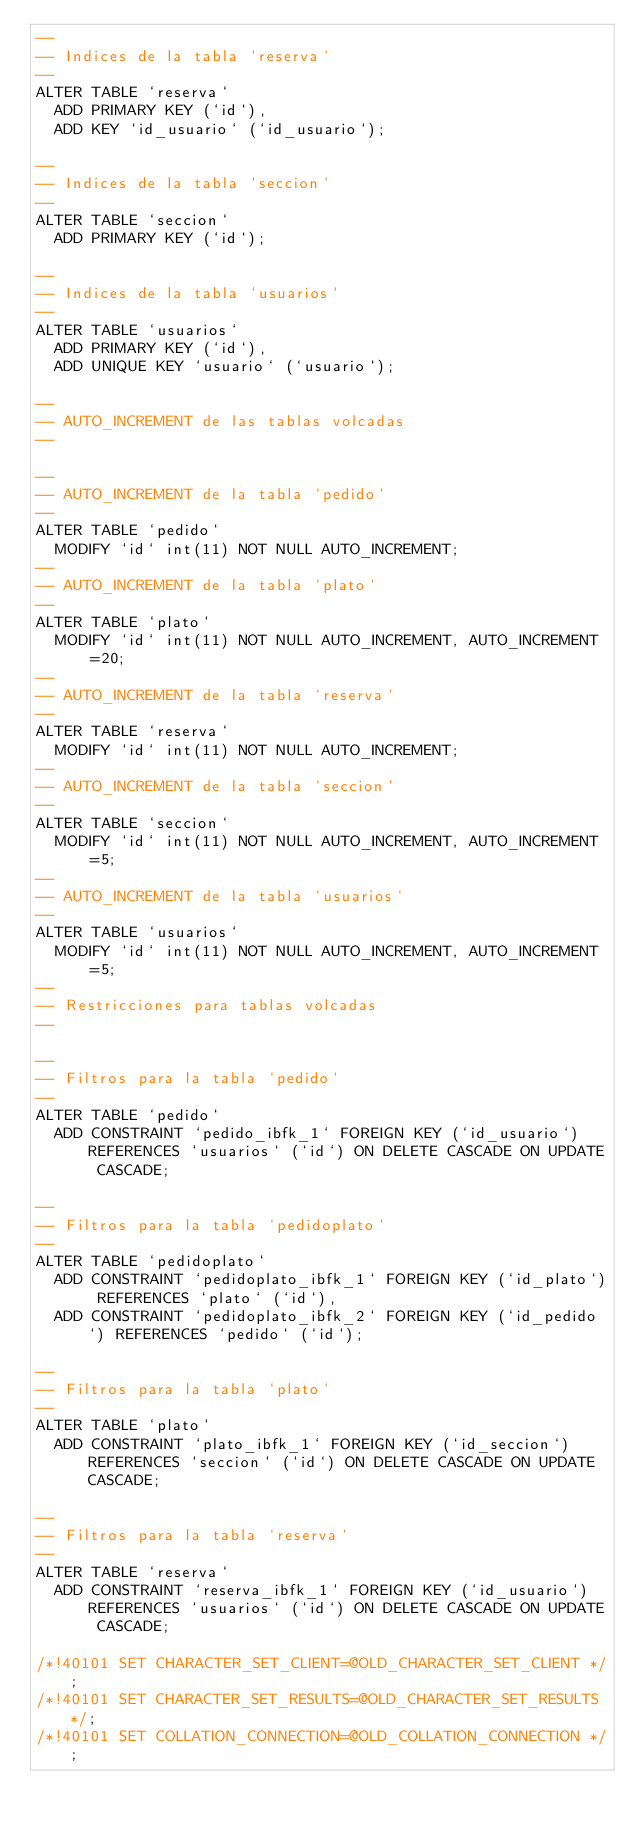<code> <loc_0><loc_0><loc_500><loc_500><_SQL_>--
-- Indices de la tabla `reserva`
--
ALTER TABLE `reserva`
  ADD PRIMARY KEY (`id`),
  ADD KEY `id_usuario` (`id_usuario`);

--
-- Indices de la tabla `seccion`
--
ALTER TABLE `seccion`
  ADD PRIMARY KEY (`id`);

--
-- Indices de la tabla `usuarios`
--
ALTER TABLE `usuarios`
  ADD PRIMARY KEY (`id`),
  ADD UNIQUE KEY `usuario` (`usuario`);

--
-- AUTO_INCREMENT de las tablas volcadas
--

--
-- AUTO_INCREMENT de la tabla `pedido`
--
ALTER TABLE `pedido`
  MODIFY `id` int(11) NOT NULL AUTO_INCREMENT;
--
-- AUTO_INCREMENT de la tabla `plato`
--
ALTER TABLE `plato`
  MODIFY `id` int(11) NOT NULL AUTO_INCREMENT, AUTO_INCREMENT=20;
--
-- AUTO_INCREMENT de la tabla `reserva`
--
ALTER TABLE `reserva`
  MODIFY `id` int(11) NOT NULL AUTO_INCREMENT;
--
-- AUTO_INCREMENT de la tabla `seccion`
--
ALTER TABLE `seccion`
  MODIFY `id` int(11) NOT NULL AUTO_INCREMENT, AUTO_INCREMENT=5;
--
-- AUTO_INCREMENT de la tabla `usuarios`
--
ALTER TABLE `usuarios`
  MODIFY `id` int(11) NOT NULL AUTO_INCREMENT, AUTO_INCREMENT=5;
--
-- Restricciones para tablas volcadas
--

--
-- Filtros para la tabla `pedido`
--
ALTER TABLE `pedido`
  ADD CONSTRAINT `pedido_ibfk_1` FOREIGN KEY (`id_usuario`) REFERENCES `usuarios` (`id`) ON DELETE CASCADE ON UPDATE CASCADE;

--
-- Filtros para la tabla `pedidoplato`
--
ALTER TABLE `pedidoplato`
  ADD CONSTRAINT `pedidoplato_ibfk_1` FOREIGN KEY (`id_plato`) REFERENCES `plato` (`id`),
  ADD CONSTRAINT `pedidoplato_ibfk_2` FOREIGN KEY (`id_pedido`) REFERENCES `pedido` (`id`);

--
-- Filtros para la tabla `plato`
--
ALTER TABLE `plato`
  ADD CONSTRAINT `plato_ibfk_1` FOREIGN KEY (`id_seccion`) REFERENCES `seccion` (`id`) ON DELETE CASCADE ON UPDATE CASCADE;

--
-- Filtros para la tabla `reserva`
--
ALTER TABLE `reserva`
  ADD CONSTRAINT `reserva_ibfk_1` FOREIGN KEY (`id_usuario`) REFERENCES `usuarios` (`id`) ON DELETE CASCADE ON UPDATE CASCADE;

/*!40101 SET CHARACTER_SET_CLIENT=@OLD_CHARACTER_SET_CLIENT */;
/*!40101 SET CHARACTER_SET_RESULTS=@OLD_CHARACTER_SET_RESULTS */;
/*!40101 SET COLLATION_CONNECTION=@OLD_COLLATION_CONNECTION */;
</code> 